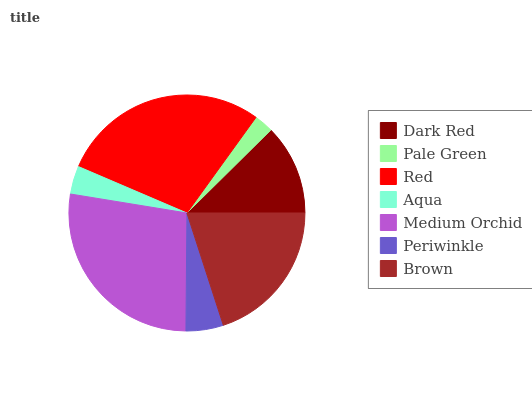Is Pale Green the minimum?
Answer yes or no. Yes. Is Red the maximum?
Answer yes or no. Yes. Is Red the minimum?
Answer yes or no. No. Is Pale Green the maximum?
Answer yes or no. No. Is Red greater than Pale Green?
Answer yes or no. Yes. Is Pale Green less than Red?
Answer yes or no. Yes. Is Pale Green greater than Red?
Answer yes or no. No. Is Red less than Pale Green?
Answer yes or no. No. Is Dark Red the high median?
Answer yes or no. Yes. Is Dark Red the low median?
Answer yes or no. Yes. Is Medium Orchid the high median?
Answer yes or no. No. Is Aqua the low median?
Answer yes or no. No. 